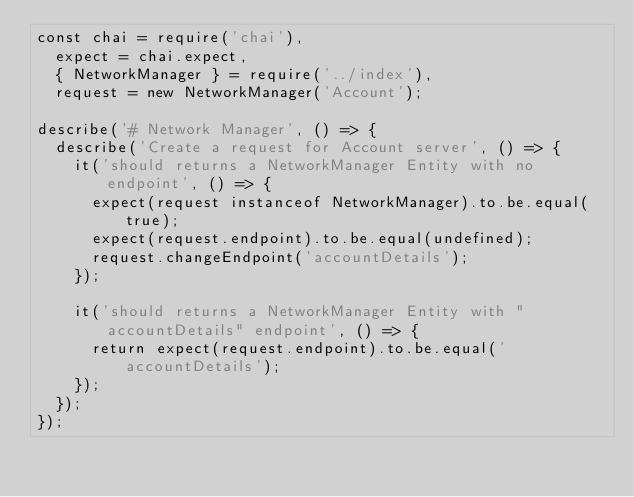Convert code to text. <code><loc_0><loc_0><loc_500><loc_500><_JavaScript_>const chai = require('chai'),
  expect = chai.expect,
  { NetworkManager } = require('../index'),
  request = new NetworkManager('Account');

describe('# Network Manager', () => {
  describe('Create a request for Account server', () => {
    it('should returns a NetworkManager Entity with no endpoint', () => {
      expect(request instanceof NetworkManager).to.be.equal(true);
      expect(request.endpoint).to.be.equal(undefined);
      request.changeEndpoint('accountDetails');
    });

    it('should returns a NetworkManager Entity with "accountDetails" endpoint', () => {
      return expect(request.endpoint).to.be.equal('accountDetails');
    });
  });
});
</code> 